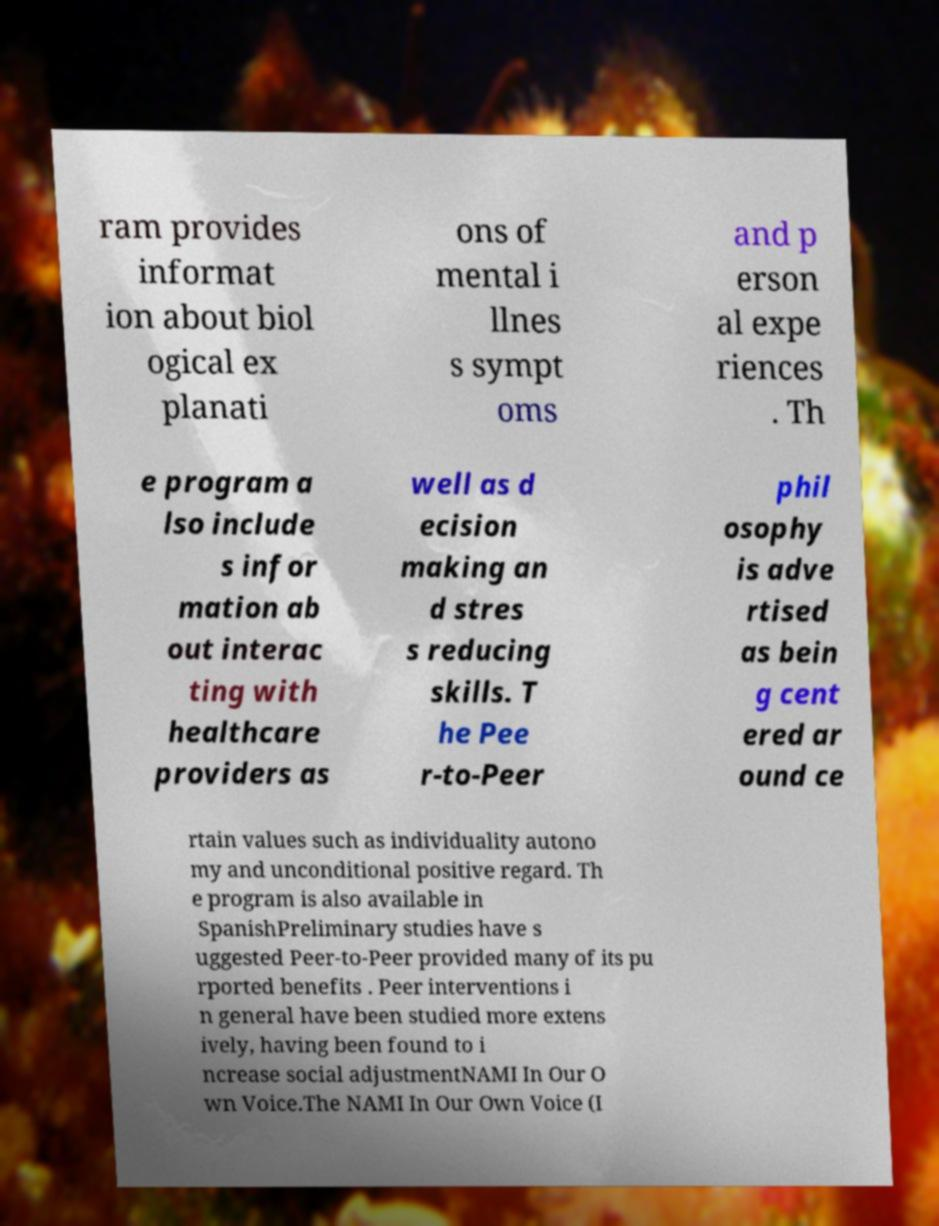Can you accurately transcribe the text from the provided image for me? ram provides informat ion about biol ogical ex planati ons of mental i llnes s sympt oms and p erson al expe riences . Th e program a lso include s infor mation ab out interac ting with healthcare providers as well as d ecision making an d stres s reducing skills. T he Pee r-to-Peer phil osophy is adve rtised as bein g cent ered ar ound ce rtain values such as individuality autono my and unconditional positive regard. Th e program is also available in SpanishPreliminary studies have s uggested Peer-to-Peer provided many of its pu rported benefits . Peer interventions i n general have been studied more extens ively, having been found to i ncrease social adjustmentNAMI In Our O wn Voice.The NAMI In Our Own Voice (I 